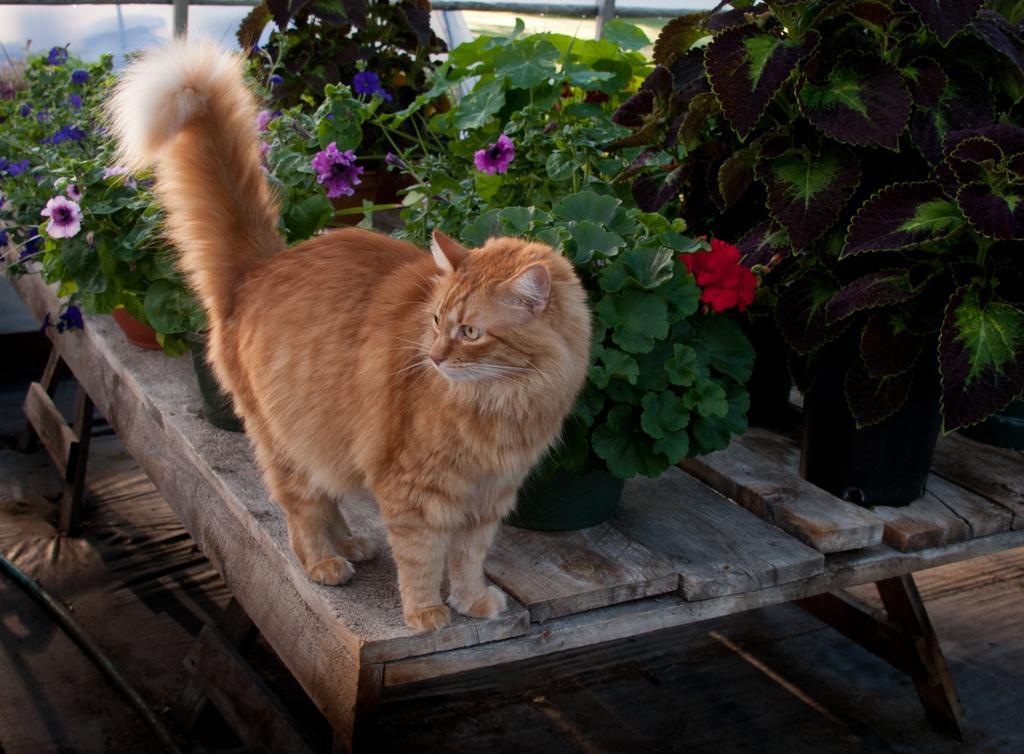How would you summarize this image in a sentence or two? In this picture there is a cat on the table. There are many flower pots on the table. 